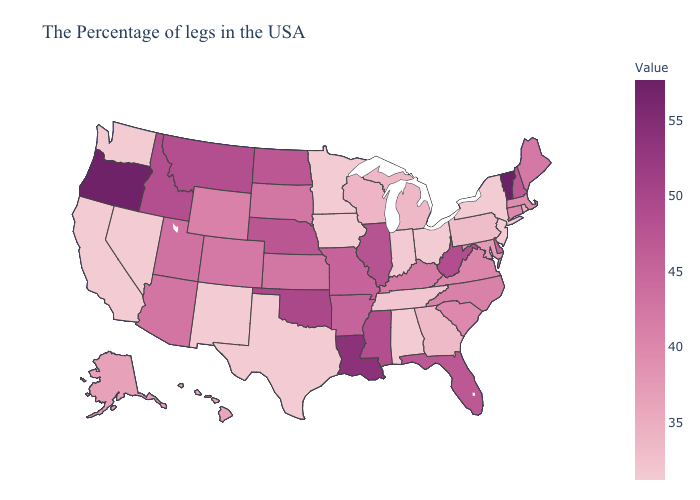Among the states that border Iowa , which have the lowest value?
Give a very brief answer. Minnesota. Does Maryland have the highest value in the USA?
Give a very brief answer. No. Among the states that border New Mexico , which have the lowest value?
Write a very short answer. Texas. Does New York have the highest value in the Northeast?
Write a very short answer. No. Which states have the lowest value in the Northeast?
Quick response, please. New York, New Jersey. 